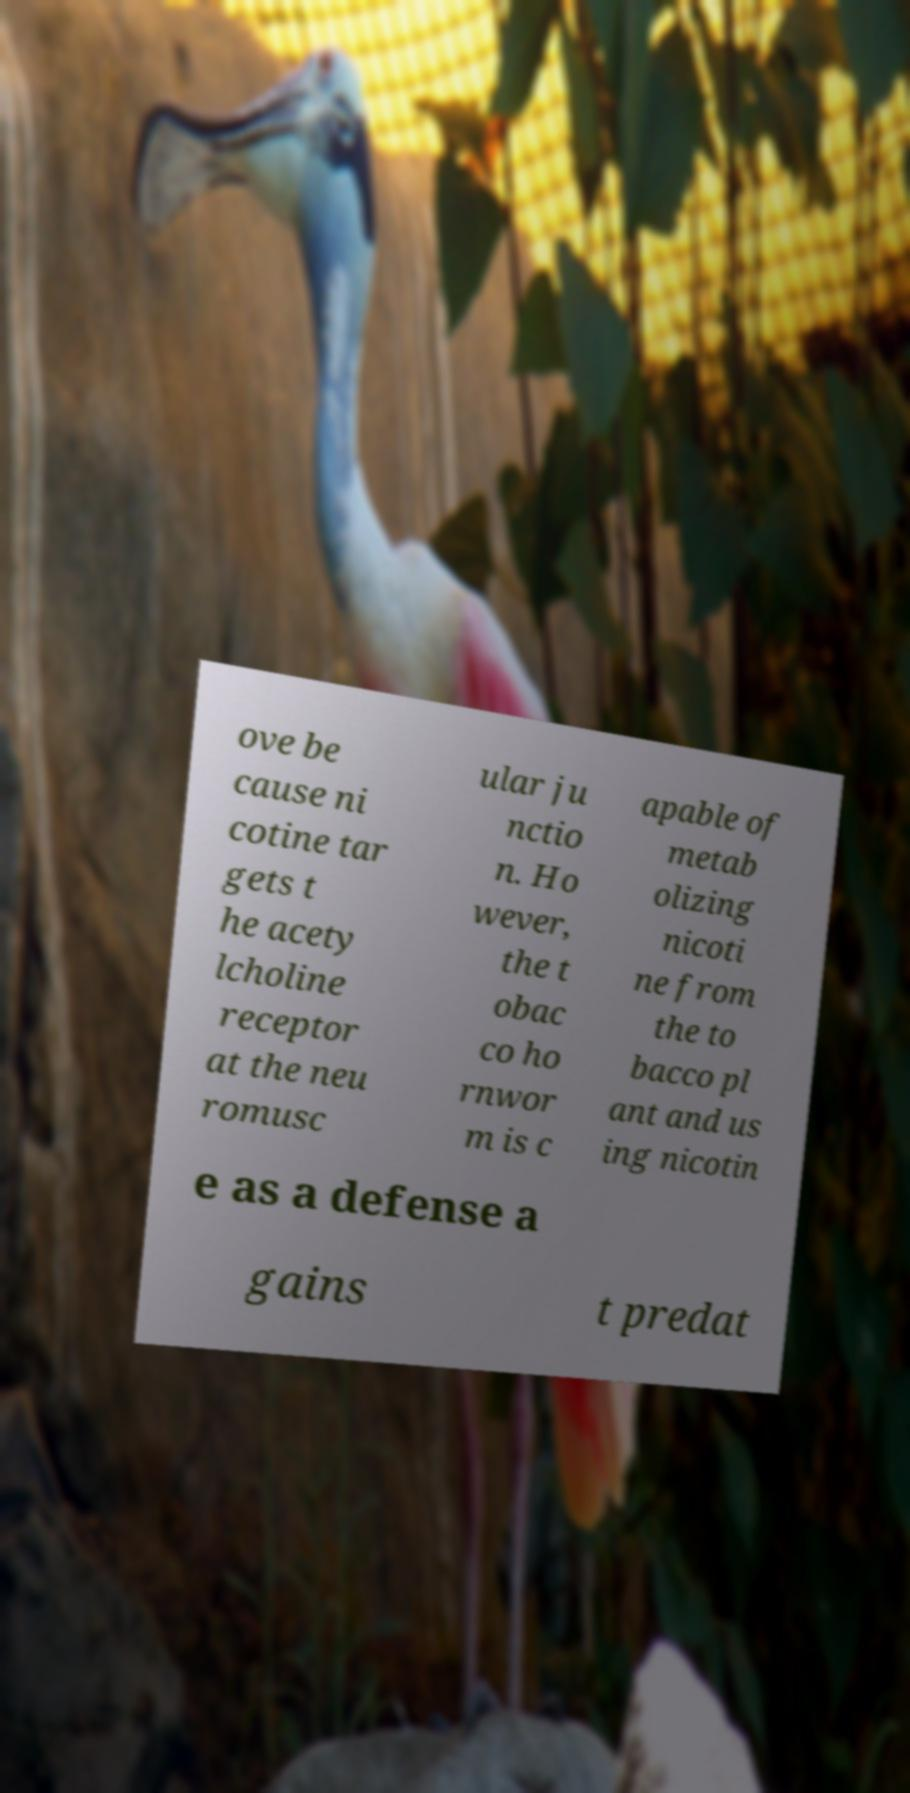Can you read and provide the text displayed in the image?This photo seems to have some interesting text. Can you extract and type it out for me? ove be cause ni cotine tar gets t he acety lcholine receptor at the neu romusc ular ju nctio n. Ho wever, the t obac co ho rnwor m is c apable of metab olizing nicoti ne from the to bacco pl ant and us ing nicotin e as a defense a gains t predat 